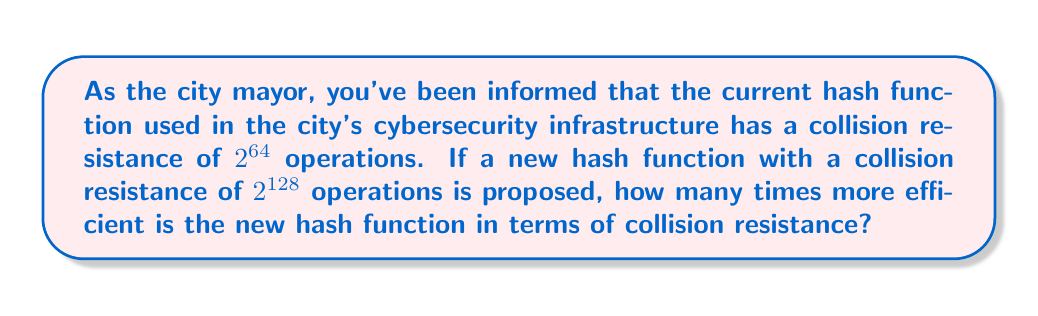Provide a solution to this math problem. To solve this problem, we need to compare the collision resistance of the two hash functions:

1) Current hash function: $2^{64}$ operations
2) Proposed hash function: $2^{128}$ operations

The efficiency in terms of collision resistance can be calculated by dividing the number of operations required for the new hash function by the number of operations required for the current hash function:

$$\text{Efficiency} = \frac{2^{128}}{2^{64}}$$

To simplify this, we can use the laws of exponents:

$$2^{128} \div 2^{64} = 2^{128-64} = 2^{64}$$

Therefore, the new hash function is $2^{64}$ times more efficient in terms of collision resistance.

To give a sense of scale, $2^{64}$ is approximately equal to $1.8 \times 10^{19}$, which is an enormously large number. This means the new hash function is significantly more resistant to collisions and thus much more secure against potential cyber attacks.
Answer: $2^{64}$ times more efficient 